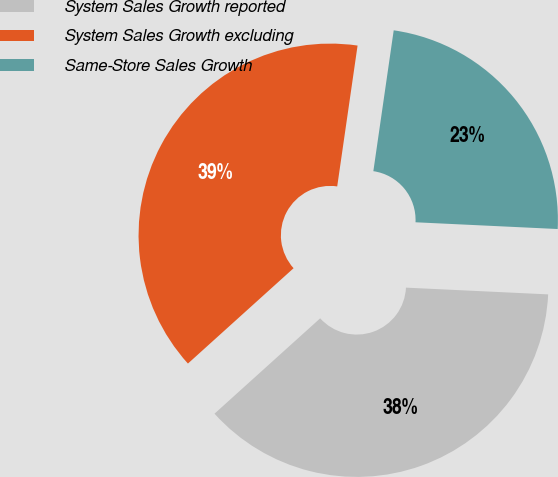Convert chart. <chart><loc_0><loc_0><loc_500><loc_500><pie_chart><fcel>System Sales Growth reported<fcel>System Sales Growth excluding<fcel>Same-Store Sales Growth<nl><fcel>37.56%<fcel>38.97%<fcel>23.47%<nl></chart> 